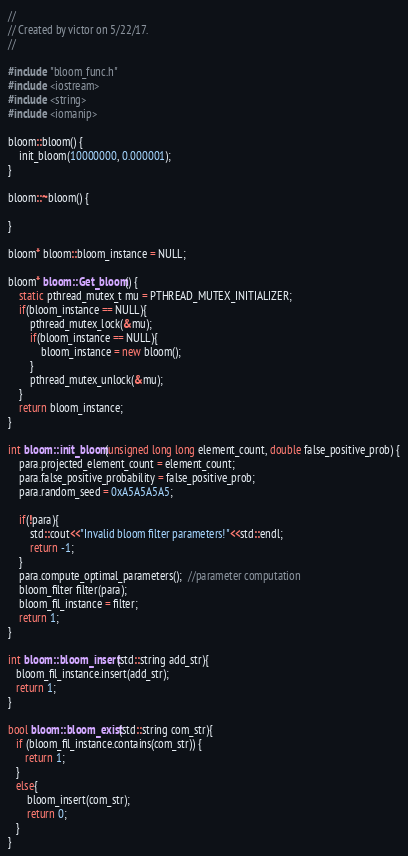<code> <loc_0><loc_0><loc_500><loc_500><_C++_>//
// Created by victor on 5/22/17.
//

#include "bloom_func.h"
#include <iostream>
#include <string>
#include <iomanip>

bloom::bloom() {
    init_bloom(10000000, 0.000001);
}

bloom::~bloom() {

}

bloom* bloom::bloom_instance = NULL;

bloom* bloom::Get_bloom() {
    static pthread_mutex_t mu = PTHREAD_MUTEX_INITIALIZER;
    if(bloom_instance == NULL){
        pthread_mutex_lock(&mu);
        if(bloom_instance == NULL){
            bloom_instance = new bloom();
        }
        pthread_mutex_unlock(&mu);
    }
    return bloom_instance;
}

int bloom::init_bloom(unsigned long long element_count, double false_positive_prob) {
    para.projected_element_count = element_count;
    para.false_positive_probability = false_positive_prob;
    para.random_seed = 0xA5A5A5A5;

    if(!para){
        std::cout<<"Invalid bloom filter parameters!"<<std::endl;
        return -1;
    }
    para.compute_optimal_parameters();  //parameter computation
    bloom_filter filter(para);
    bloom_fil_instance = filter;
    return 1;
}

int bloom::bloom_insert(std::string add_str){
   bloom_fil_instance.insert(add_str);
   return 1;
}

bool bloom::bloom_exist(std::string com_str){
   if (bloom_fil_instance.contains(com_str)) {
      return 1;
   }
   else{
       bloom_insert(com_str);
       return 0;
   }
}
</code> 